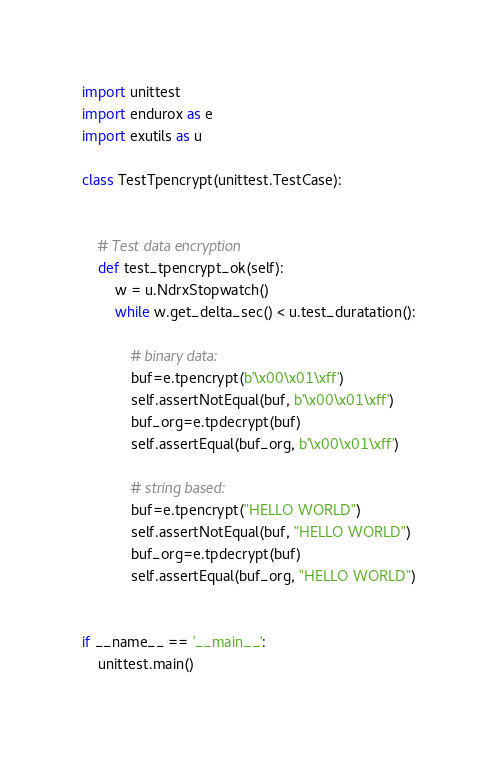Convert code to text. <code><loc_0><loc_0><loc_500><loc_500><_Python_>import unittest
import endurox as e
import exutils as u

class TestTpencrypt(unittest.TestCase):


    # Test data encryption
    def test_tpencrypt_ok(self):
        w = u.NdrxStopwatch()
        while w.get_delta_sec() < u.test_duratation():
            
            # binary data:
            buf=e.tpencrypt(b'\x00\x01\xff')
            self.assertNotEqual(buf, b'\x00\x01\xff')
            buf_org=e.tpdecrypt(buf)
            self.assertEqual(buf_org, b'\x00\x01\xff')

            # string based:
            buf=e.tpencrypt("HELLO WORLD")
            self.assertNotEqual(buf, "HELLO WORLD")
            buf_org=e.tpdecrypt(buf)
            self.assertEqual(buf_org, "HELLO WORLD")
            

if __name__ == '__main__':
    unittest.main()

</code> 